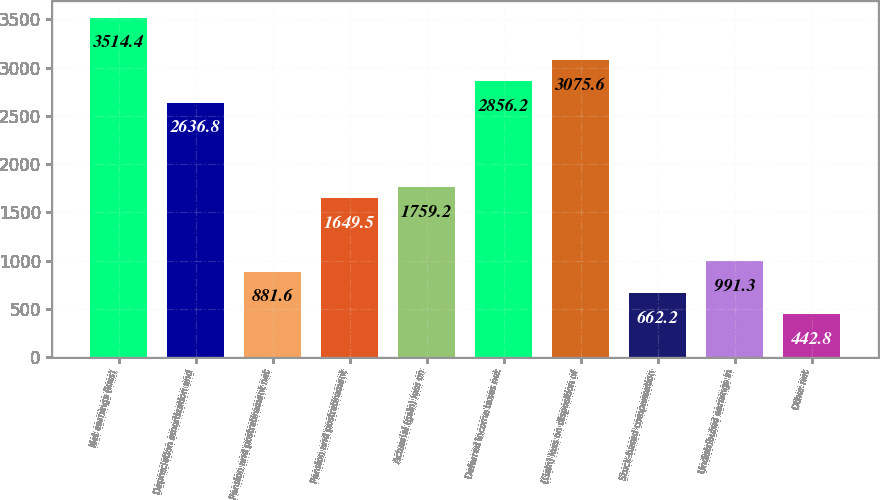<chart> <loc_0><loc_0><loc_500><loc_500><bar_chart><fcel>Net earnings (loss)<fcel>Depreciation amortization and<fcel>Pension and postretirement net<fcel>Pension and postretirement<fcel>Actuarial (gain) loss on<fcel>Deferred income taxes net<fcel>(Gain) loss on disposition of<fcel>Stock-based compensation<fcel>Undistributed earnings in<fcel>Other net<nl><fcel>3514.4<fcel>2636.8<fcel>881.6<fcel>1649.5<fcel>1759.2<fcel>2856.2<fcel>3075.6<fcel>662.2<fcel>991.3<fcel>442.8<nl></chart> 